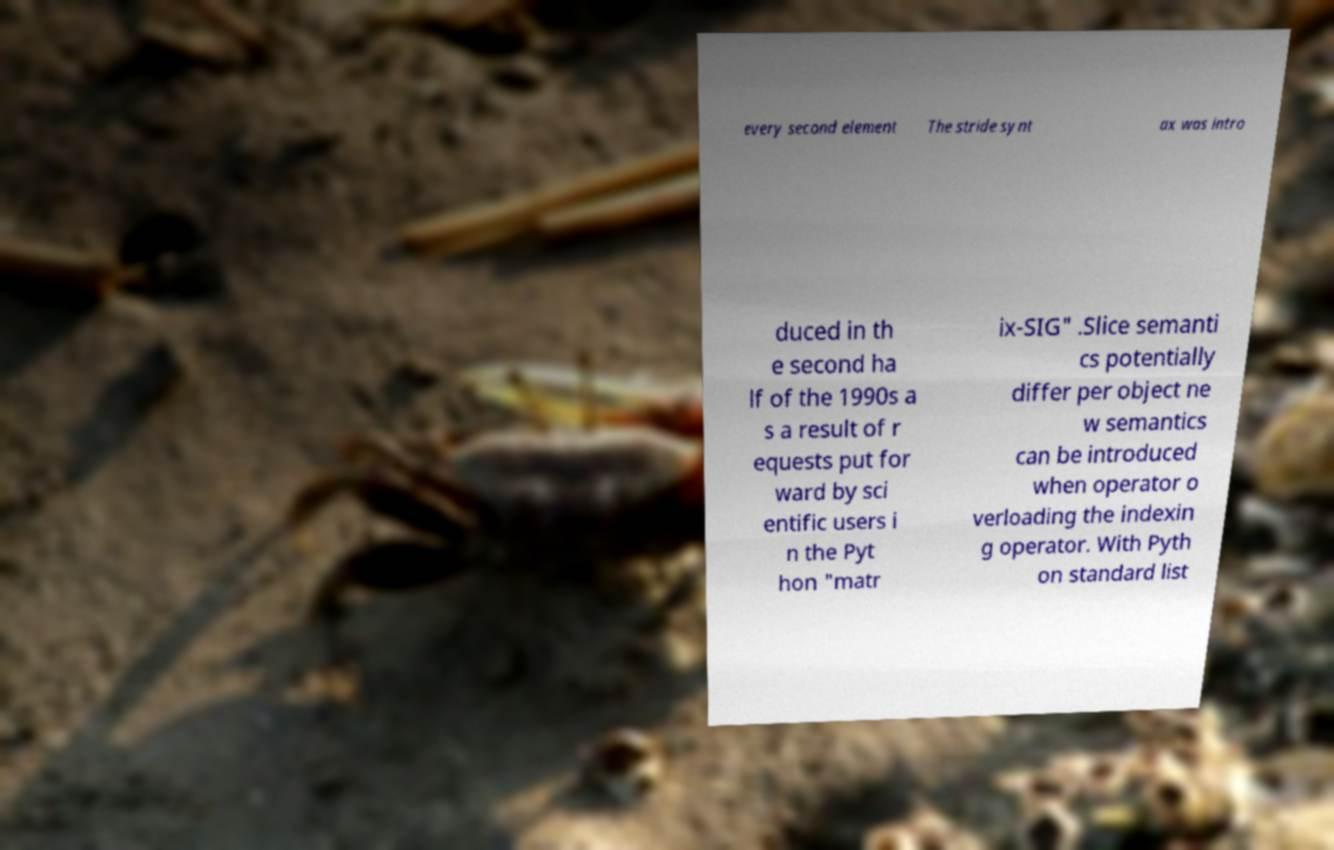I need the written content from this picture converted into text. Can you do that? every second element The stride synt ax was intro duced in th e second ha lf of the 1990s a s a result of r equests put for ward by sci entific users i n the Pyt hon "matr ix-SIG" .Slice semanti cs potentially differ per object ne w semantics can be introduced when operator o verloading the indexin g operator. With Pyth on standard list 